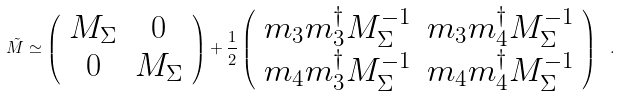<formula> <loc_0><loc_0><loc_500><loc_500>\tilde { M } \simeq \left ( \begin{array} { c c } M _ { \Sigma } & 0 \\ 0 & M _ { \Sigma } \end{array} \right ) + \frac { 1 } { 2 } \left ( \begin{array} { c c } m _ { 3 } m _ { 3 } ^ { \dagger } M ^ { - 1 } _ { \Sigma } & m _ { 3 } m _ { 4 } ^ { \dagger } M ^ { - 1 } _ { \Sigma } \\ m _ { 4 } m _ { 3 } ^ { \dagger } M ^ { - 1 } _ { \Sigma } & m _ { 4 } m _ { 4 } ^ { \dagger } M ^ { - 1 } _ { \Sigma } \end{array} \right ) \ .</formula> 